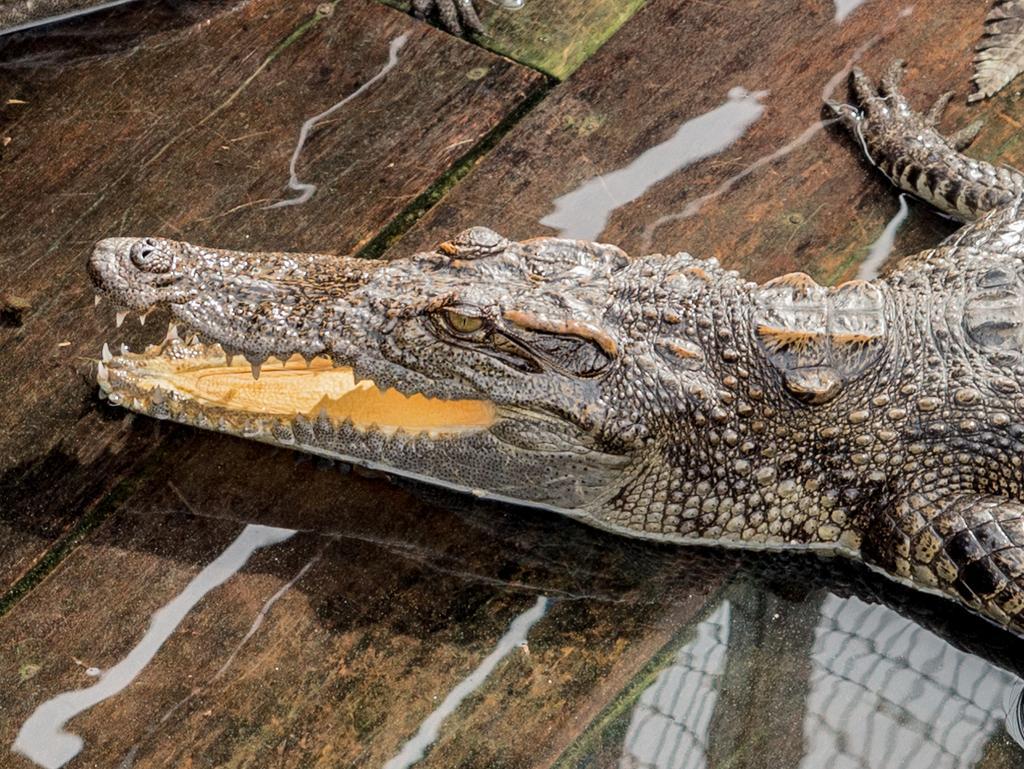Please provide a concise description of this image. In the center of the image there is crocodile. 